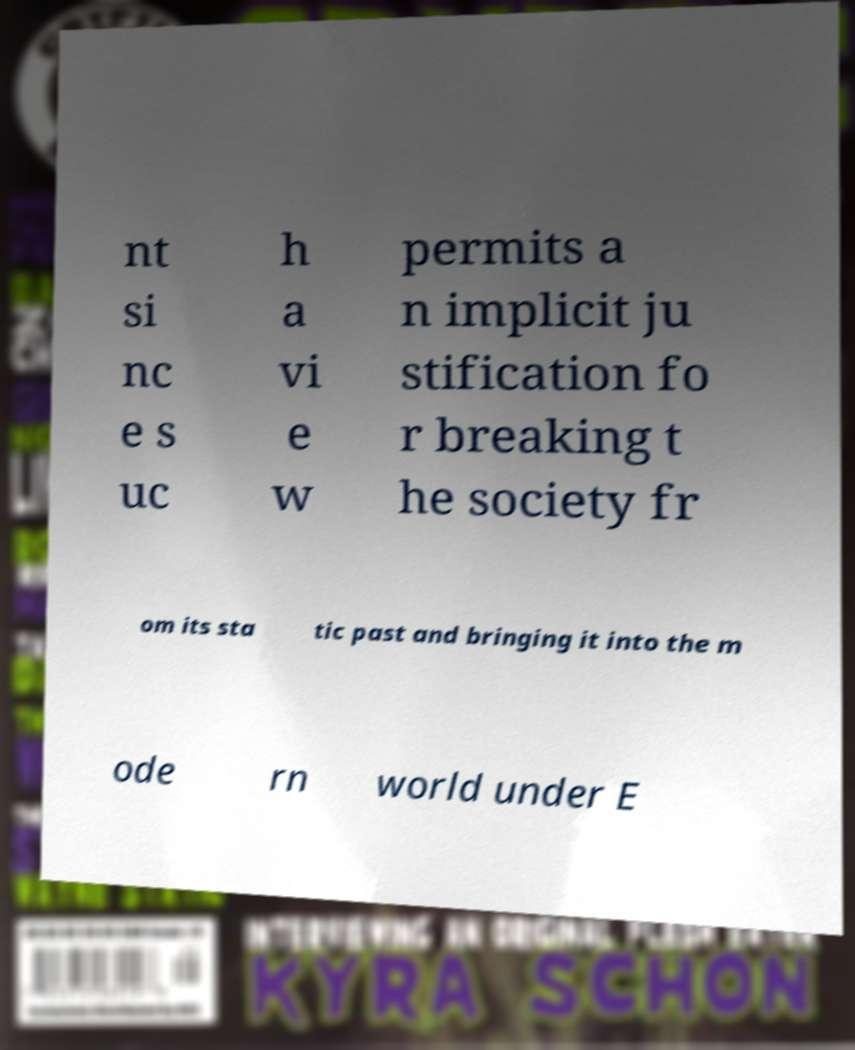For documentation purposes, I need the text within this image transcribed. Could you provide that? nt si nc e s uc h a vi e w permits a n implicit ju stification fo r breaking t he society fr om its sta tic past and bringing it into the m ode rn world under E 